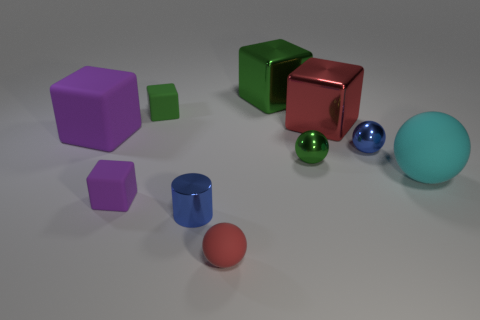Subtract all red cubes. How many cubes are left? 4 Subtract all red cubes. How many cubes are left? 4 Subtract all gray cubes. Subtract all yellow spheres. How many cubes are left? 5 Subtract all spheres. How many objects are left? 6 Subtract all tiny green things. Subtract all small red balls. How many objects are left? 7 Add 2 small things. How many small things are left? 8 Add 2 brown blocks. How many brown blocks exist? 2 Subtract 0 brown cylinders. How many objects are left? 10 